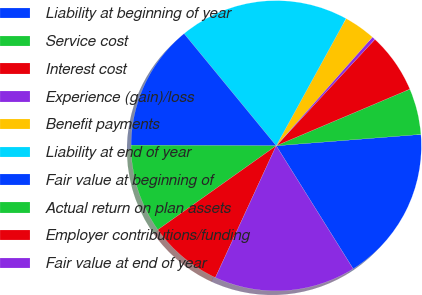<chart> <loc_0><loc_0><loc_500><loc_500><pie_chart><fcel>Liability at beginning of year<fcel>Service cost<fcel>Interest cost<fcel>Experience (gain)/loss<fcel>Benefit payments<fcel>Liability at end of year<fcel>Fair value at beginning of<fcel>Actual return on plan assets<fcel>Employer contributions/funding<fcel>Fair value at end of year<nl><fcel>17.36%<fcel>5.13%<fcel>6.72%<fcel>0.37%<fcel>3.54%<fcel>18.94%<fcel>13.99%<fcel>9.89%<fcel>8.3%<fcel>15.77%<nl></chart> 